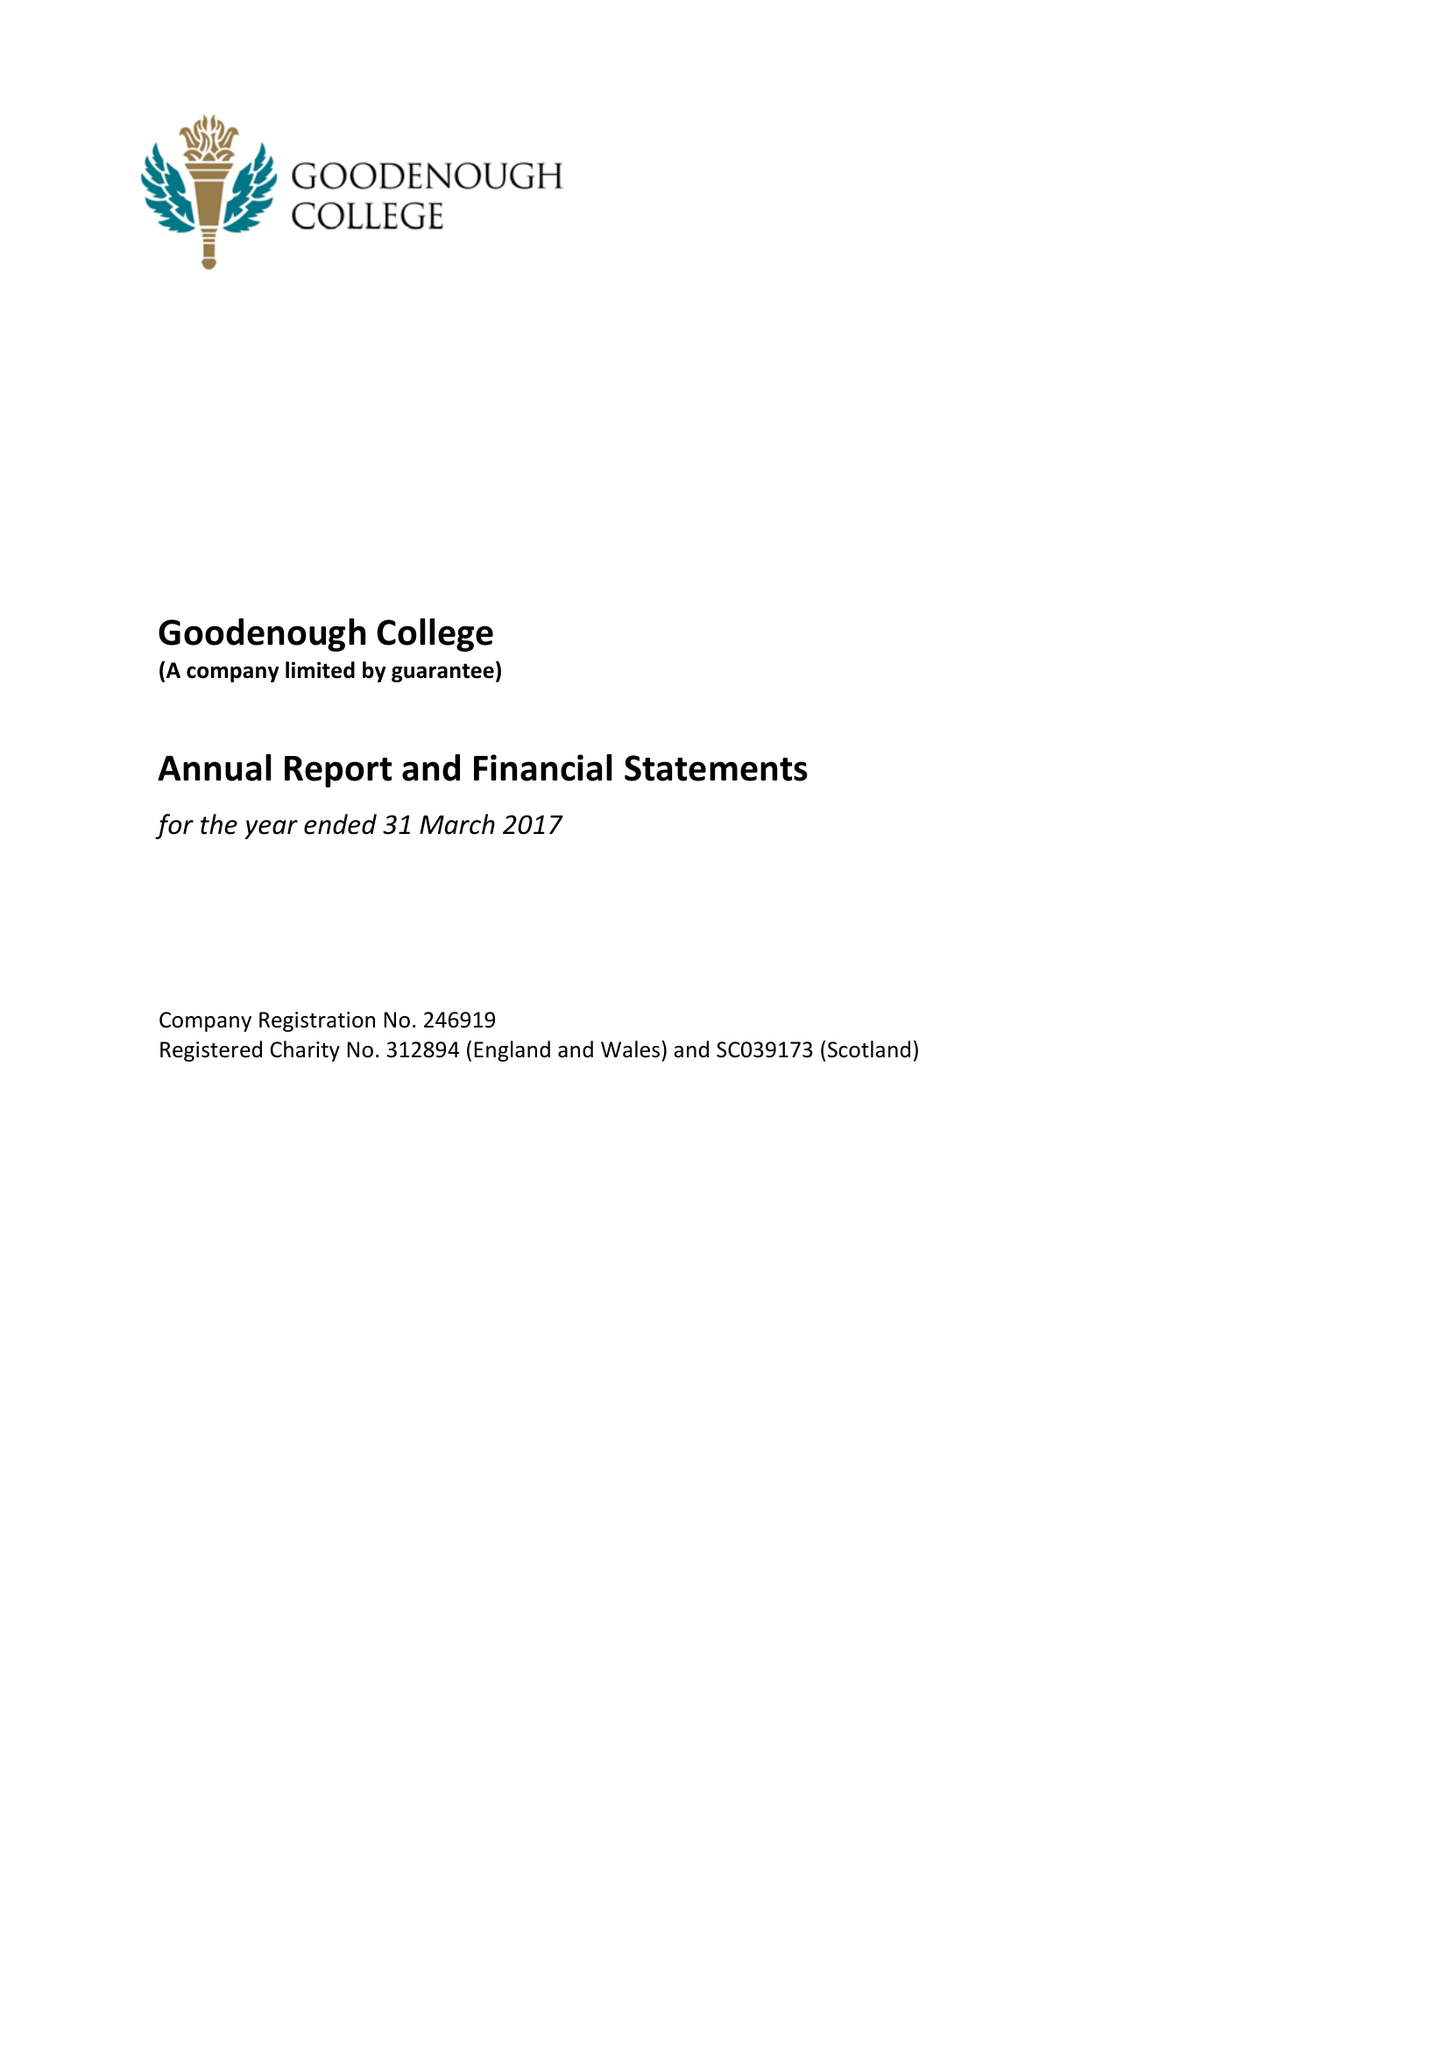What is the value for the report_date?
Answer the question using a single word or phrase. 2017-03-31 